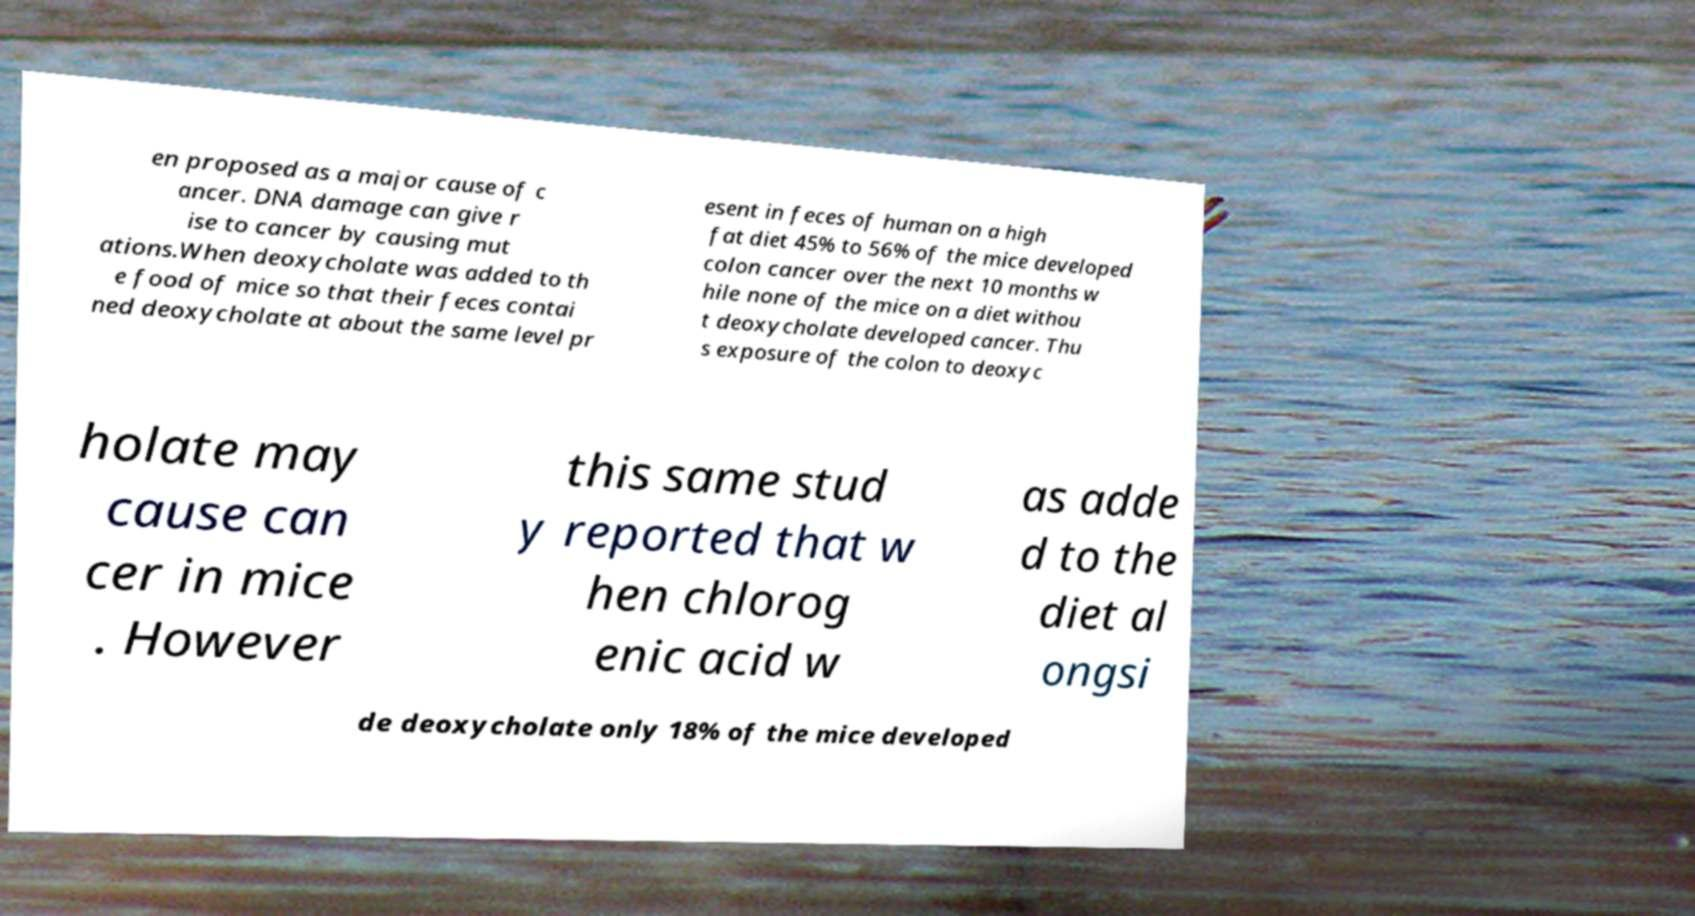Could you assist in decoding the text presented in this image and type it out clearly? en proposed as a major cause of c ancer. DNA damage can give r ise to cancer by causing mut ations.When deoxycholate was added to th e food of mice so that their feces contai ned deoxycholate at about the same level pr esent in feces of human on a high fat diet 45% to 56% of the mice developed colon cancer over the next 10 months w hile none of the mice on a diet withou t deoxycholate developed cancer. Thu s exposure of the colon to deoxyc holate may cause can cer in mice . However this same stud y reported that w hen chlorog enic acid w as adde d to the diet al ongsi de deoxycholate only 18% of the mice developed 